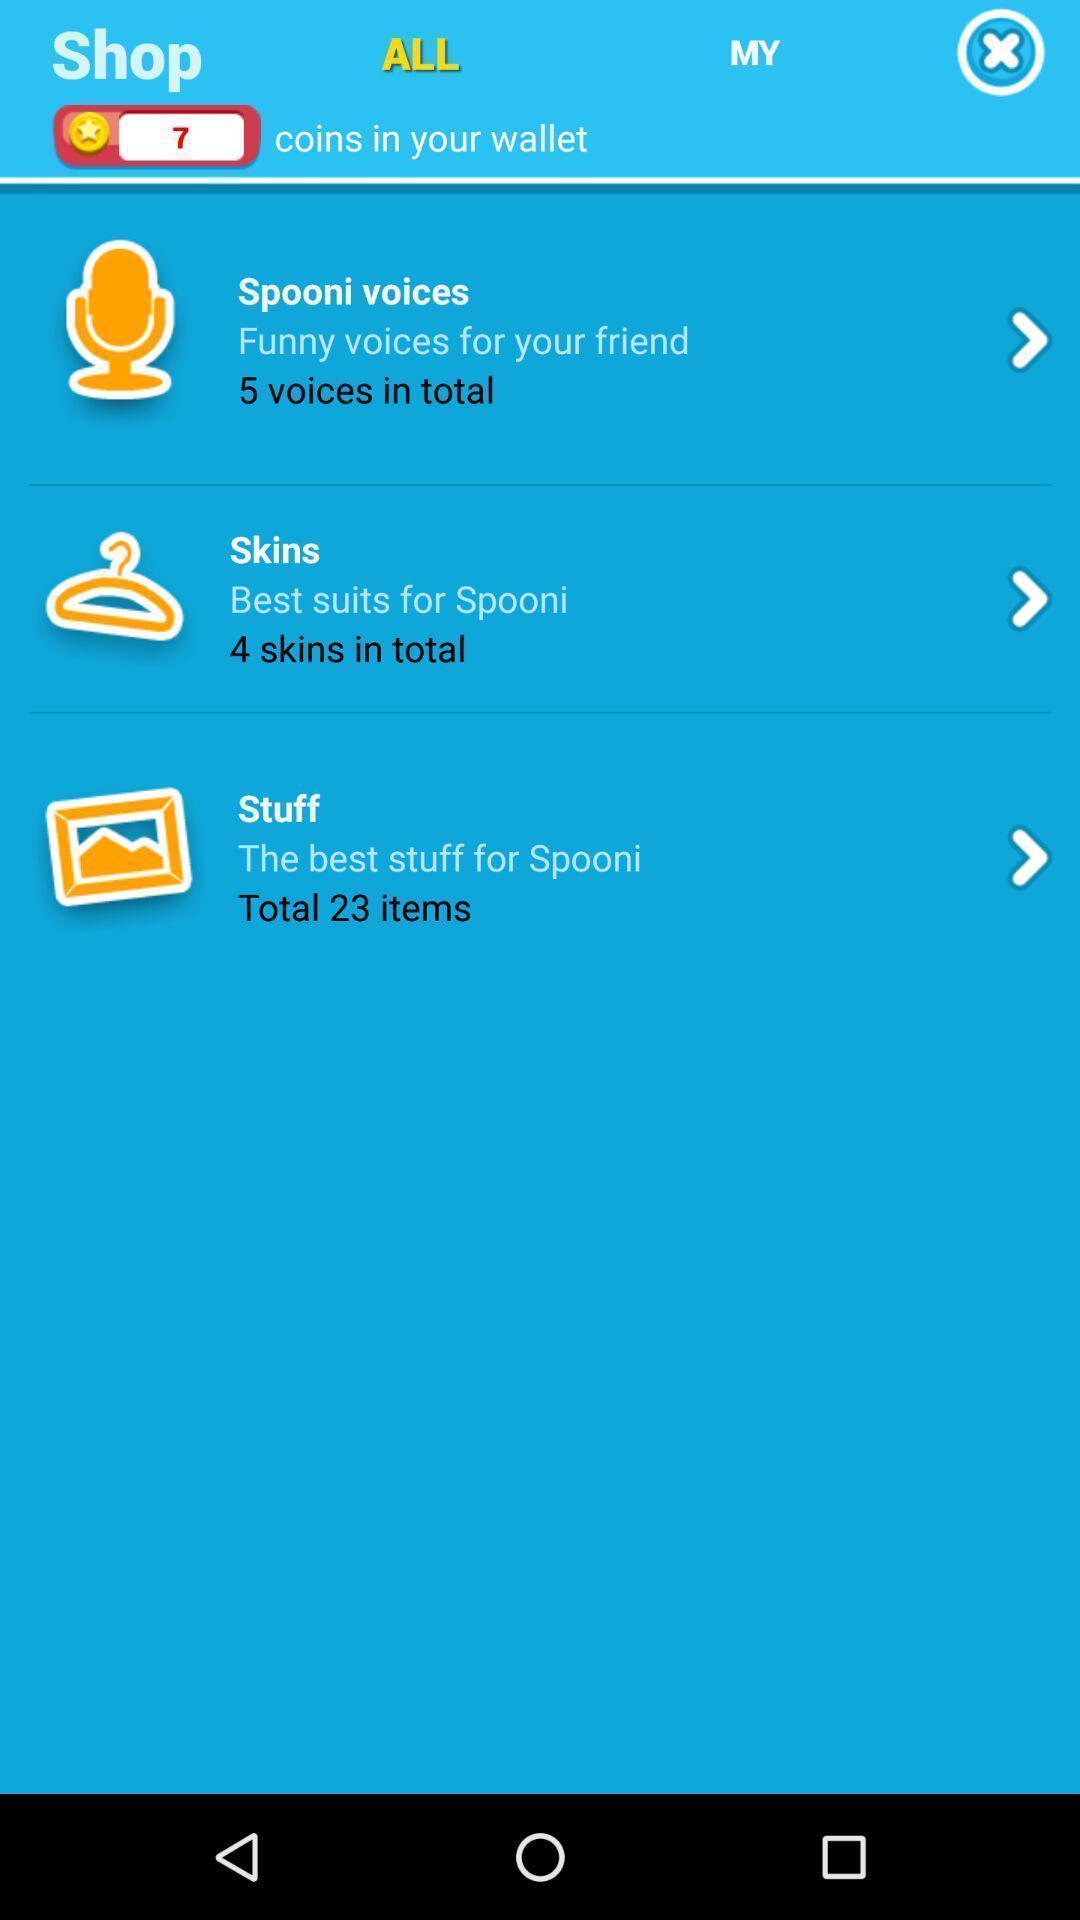Explain the elements present in this screenshot. Screen shows multiple options. 